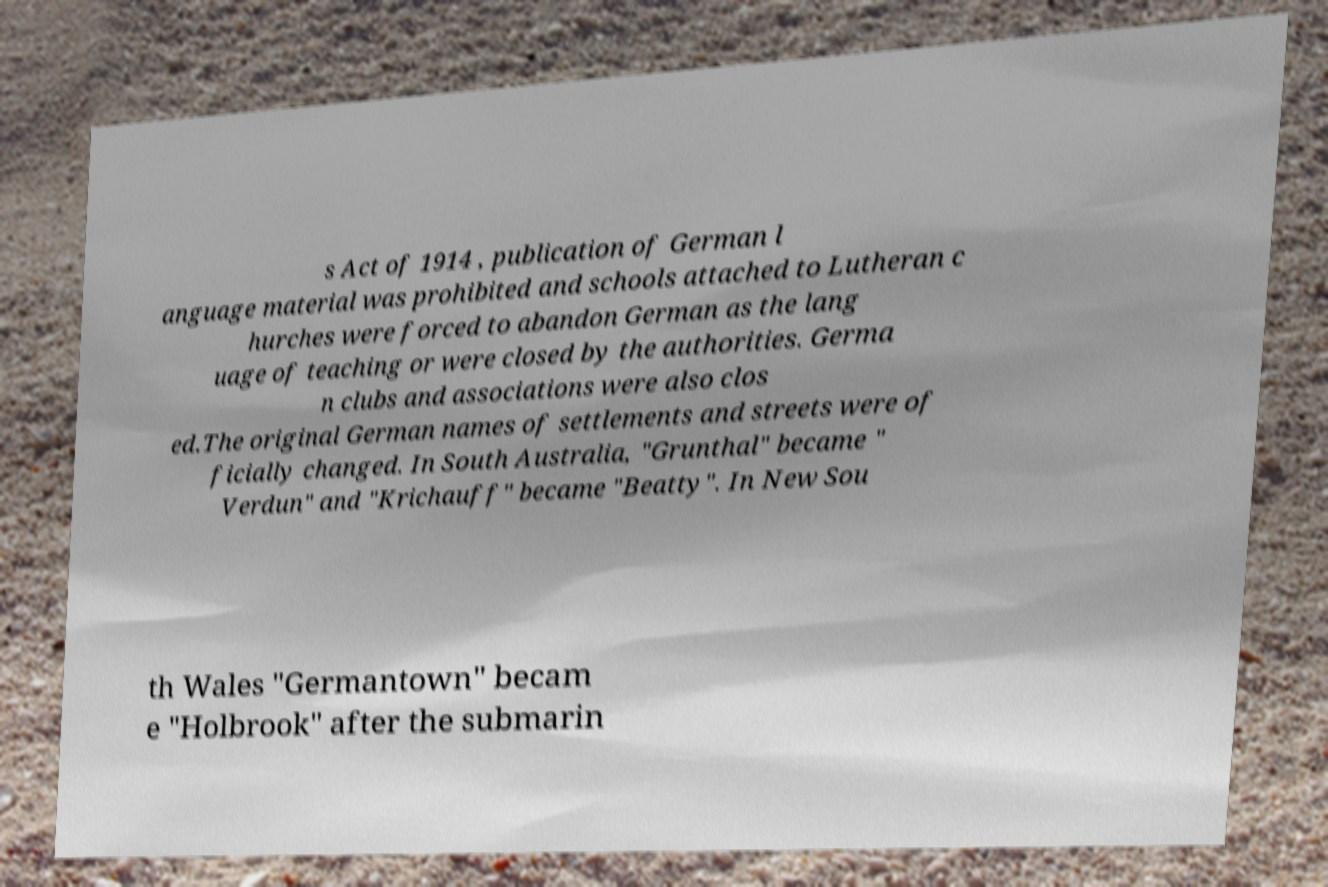I need the written content from this picture converted into text. Can you do that? s Act of 1914 , publication of German l anguage material was prohibited and schools attached to Lutheran c hurches were forced to abandon German as the lang uage of teaching or were closed by the authorities. Germa n clubs and associations were also clos ed.The original German names of settlements and streets were of ficially changed. In South Australia, "Grunthal" became " Verdun" and "Krichauff" became "Beatty". In New Sou th Wales "Germantown" becam e "Holbrook" after the submarin 